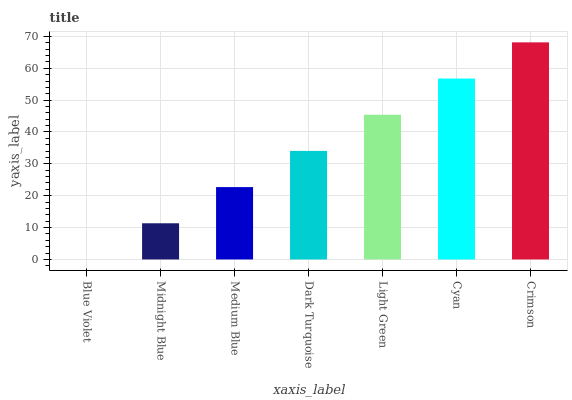Is Blue Violet the minimum?
Answer yes or no. Yes. Is Crimson the maximum?
Answer yes or no. Yes. Is Midnight Blue the minimum?
Answer yes or no. No. Is Midnight Blue the maximum?
Answer yes or no. No. Is Midnight Blue greater than Blue Violet?
Answer yes or no. Yes. Is Blue Violet less than Midnight Blue?
Answer yes or no. Yes. Is Blue Violet greater than Midnight Blue?
Answer yes or no. No. Is Midnight Blue less than Blue Violet?
Answer yes or no. No. Is Dark Turquoise the high median?
Answer yes or no. Yes. Is Dark Turquoise the low median?
Answer yes or no. Yes. Is Crimson the high median?
Answer yes or no. No. Is Light Green the low median?
Answer yes or no. No. 